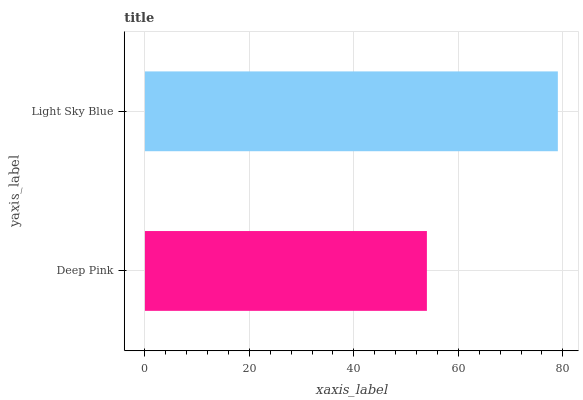Is Deep Pink the minimum?
Answer yes or no. Yes. Is Light Sky Blue the maximum?
Answer yes or no. Yes. Is Light Sky Blue the minimum?
Answer yes or no. No. Is Light Sky Blue greater than Deep Pink?
Answer yes or no. Yes. Is Deep Pink less than Light Sky Blue?
Answer yes or no. Yes. Is Deep Pink greater than Light Sky Blue?
Answer yes or no. No. Is Light Sky Blue less than Deep Pink?
Answer yes or no. No. Is Light Sky Blue the high median?
Answer yes or no. Yes. Is Deep Pink the low median?
Answer yes or no. Yes. Is Deep Pink the high median?
Answer yes or no. No. Is Light Sky Blue the low median?
Answer yes or no. No. 